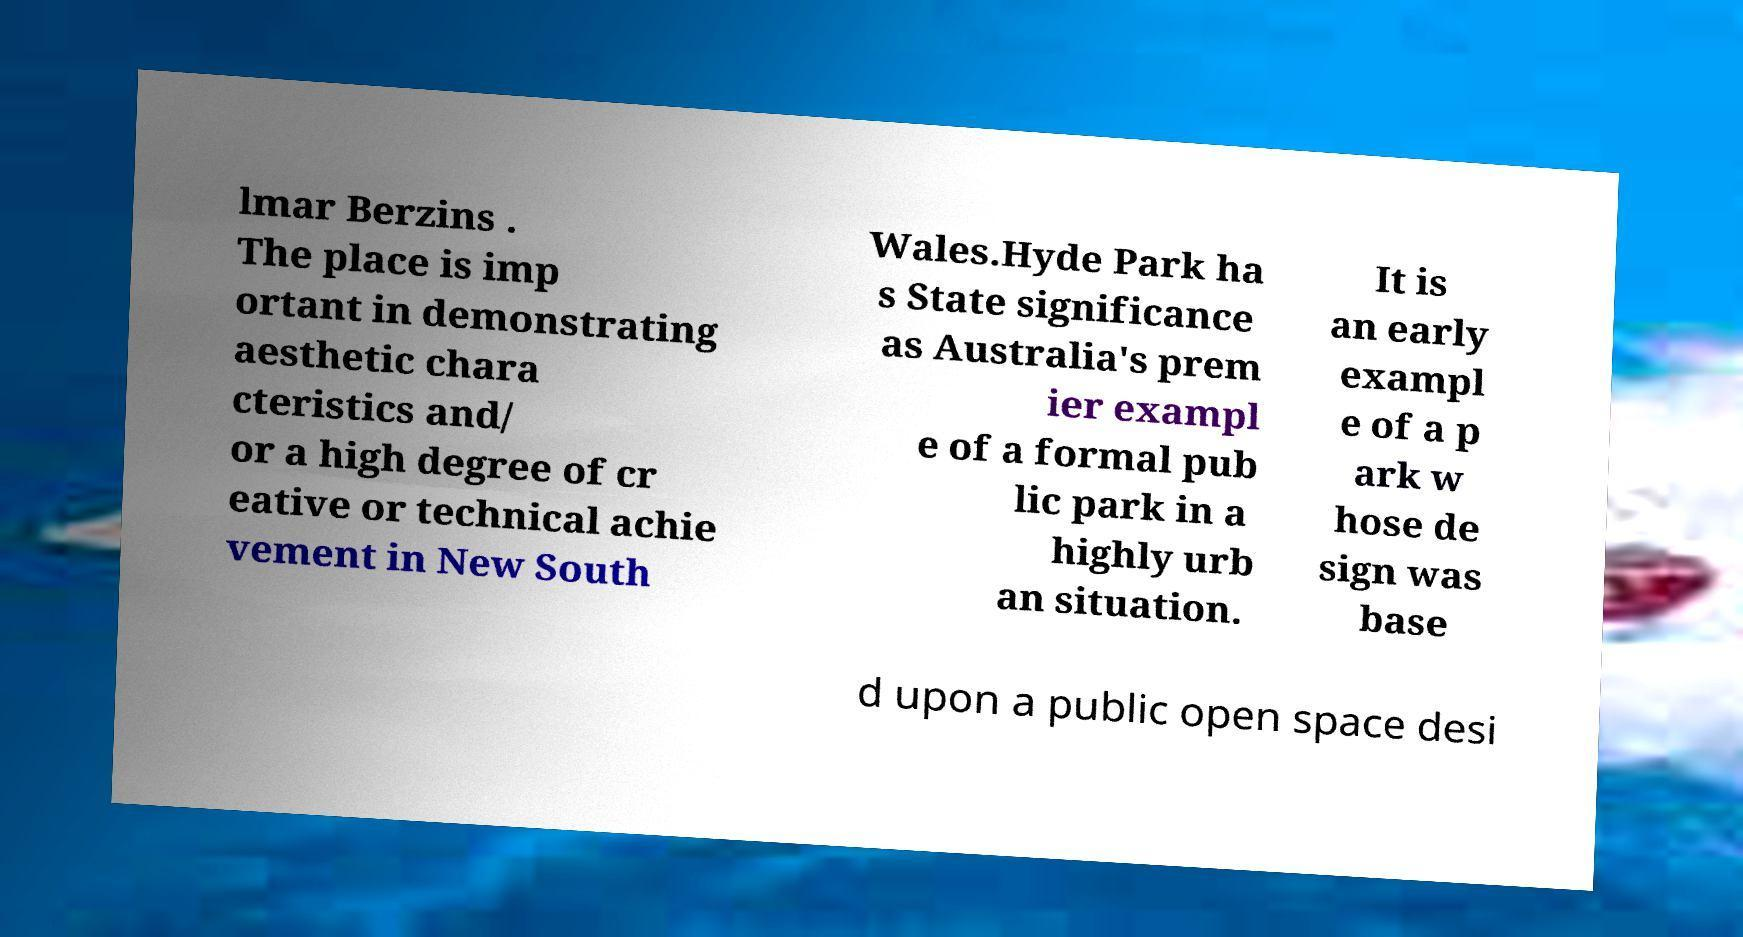Please read and relay the text visible in this image. What does it say? lmar Berzins . The place is imp ortant in demonstrating aesthetic chara cteristics and/ or a high degree of cr eative or technical achie vement in New South Wales.Hyde Park ha s State significance as Australia's prem ier exampl e of a formal pub lic park in a highly urb an situation. It is an early exampl e of a p ark w hose de sign was base d upon a public open space desi 